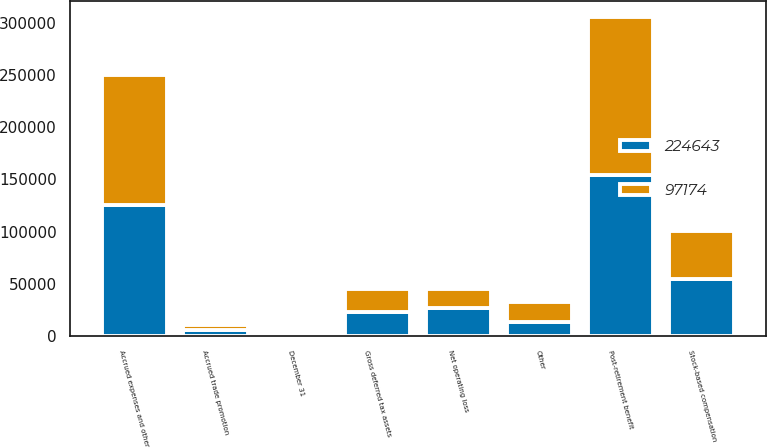Convert chart. <chart><loc_0><loc_0><loc_500><loc_500><stacked_bar_chart><ecel><fcel>December 31<fcel>Post-retirement benefit<fcel>Accrued expenses and other<fcel>Stock-based compensation<fcel>Accrued trade promotion<fcel>Net operating loss<fcel>Other<fcel>Gross deferred tax assets<nl><fcel>224643<fcel>2007<fcel>154174<fcel>126032<fcel>55003<fcel>6107<fcel>26792<fcel>14096<fcel>22825<nl><fcel>97174<fcel>2006<fcel>150794<fcel>123690<fcel>46087<fcel>4606<fcel>18858<fcel>18298<fcel>22825<nl></chart> 